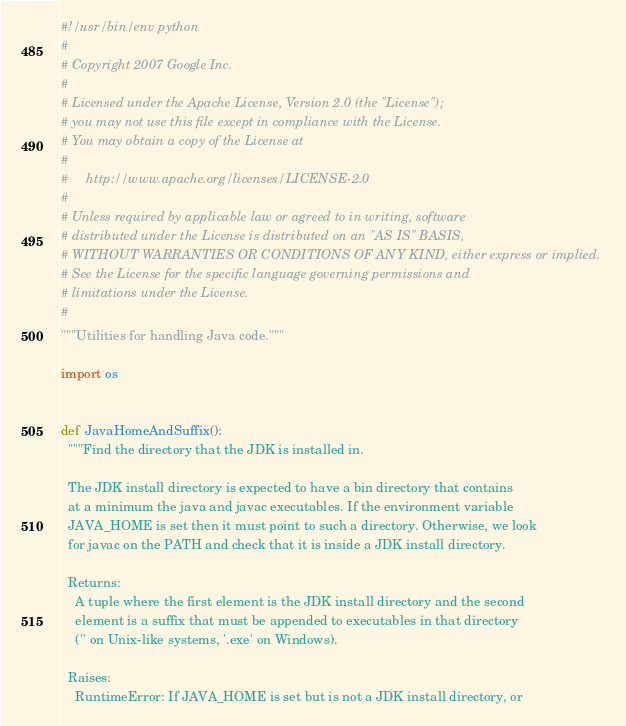Convert code to text. <code><loc_0><loc_0><loc_500><loc_500><_Python_>#!/usr/bin/env python
#
# Copyright 2007 Google Inc.
#
# Licensed under the Apache License, Version 2.0 (the "License");
# you may not use this file except in compliance with the License.
# You may obtain a copy of the License at
#
#     http://www.apache.org/licenses/LICENSE-2.0
#
# Unless required by applicable law or agreed to in writing, software
# distributed under the License is distributed on an "AS IS" BASIS,
# WITHOUT WARRANTIES OR CONDITIONS OF ANY KIND, either express or implied.
# See the License for the specific language governing permissions and
# limitations under the License.
#
"""Utilities for handling Java code."""

import os


def JavaHomeAndSuffix():
  """Find the directory that the JDK is installed in.

  The JDK install directory is expected to have a bin directory that contains
  at a minimum the java and javac executables. If the environment variable
  JAVA_HOME is set then it must point to such a directory. Otherwise, we look
  for javac on the PATH and check that it is inside a JDK install directory.

  Returns:
    A tuple where the first element is the JDK install directory and the second
    element is a suffix that must be appended to executables in that directory
    ('' on Unix-like systems, '.exe' on Windows).

  Raises:
    RuntimeError: If JAVA_HOME is set but is not a JDK install directory, or</code> 